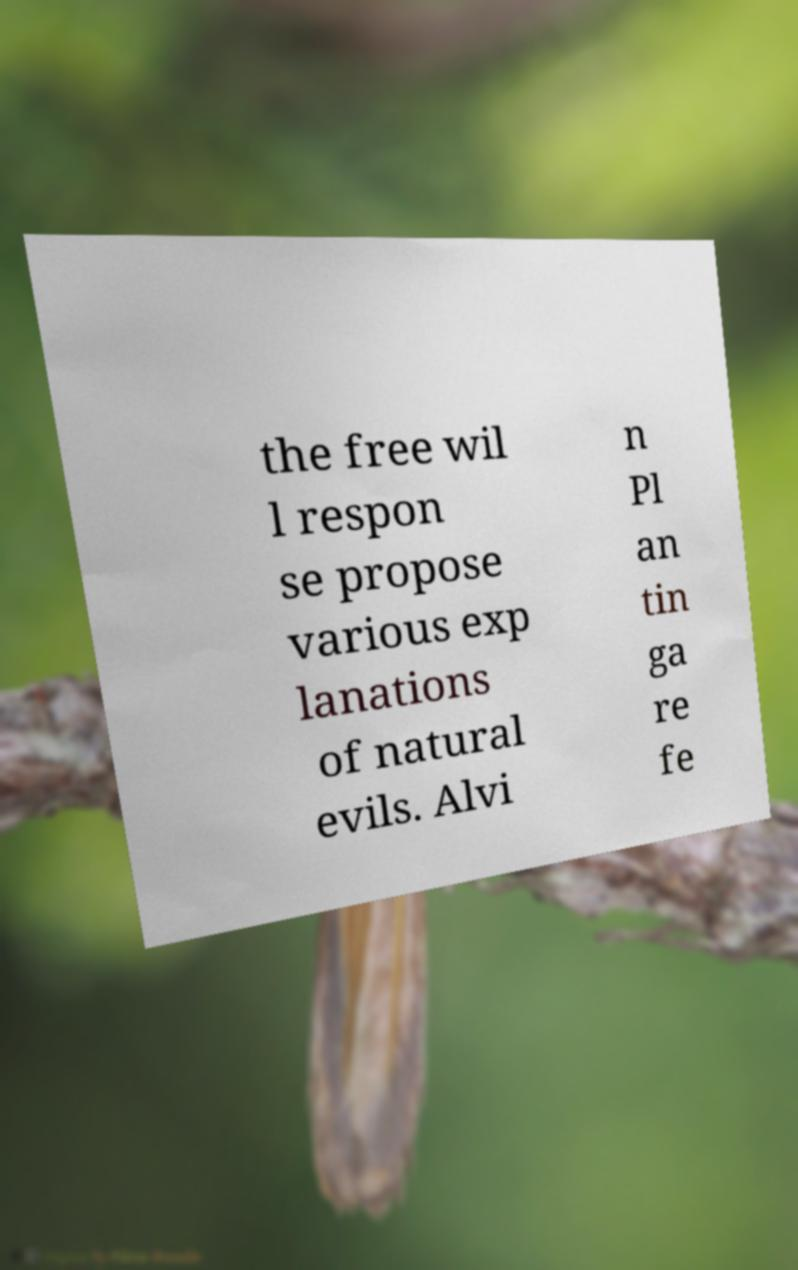Could you extract and type out the text from this image? the free wil l respon se propose various exp lanations of natural evils. Alvi n Pl an tin ga re fe 